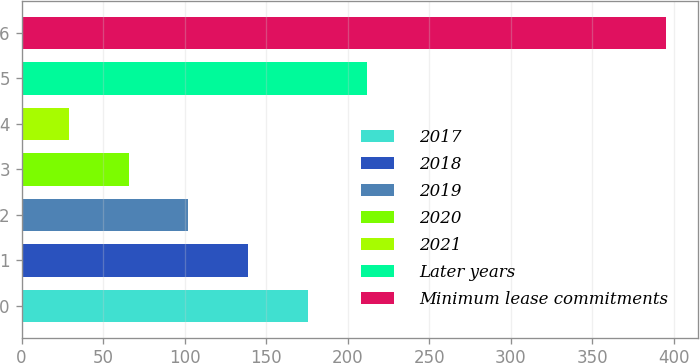Convert chart. <chart><loc_0><loc_0><loc_500><loc_500><bar_chart><fcel>2017<fcel>2018<fcel>2019<fcel>2020<fcel>2021<fcel>Later years<fcel>Minimum lease commitments<nl><fcel>175.4<fcel>138.8<fcel>102.2<fcel>65.6<fcel>29<fcel>212<fcel>395<nl></chart> 